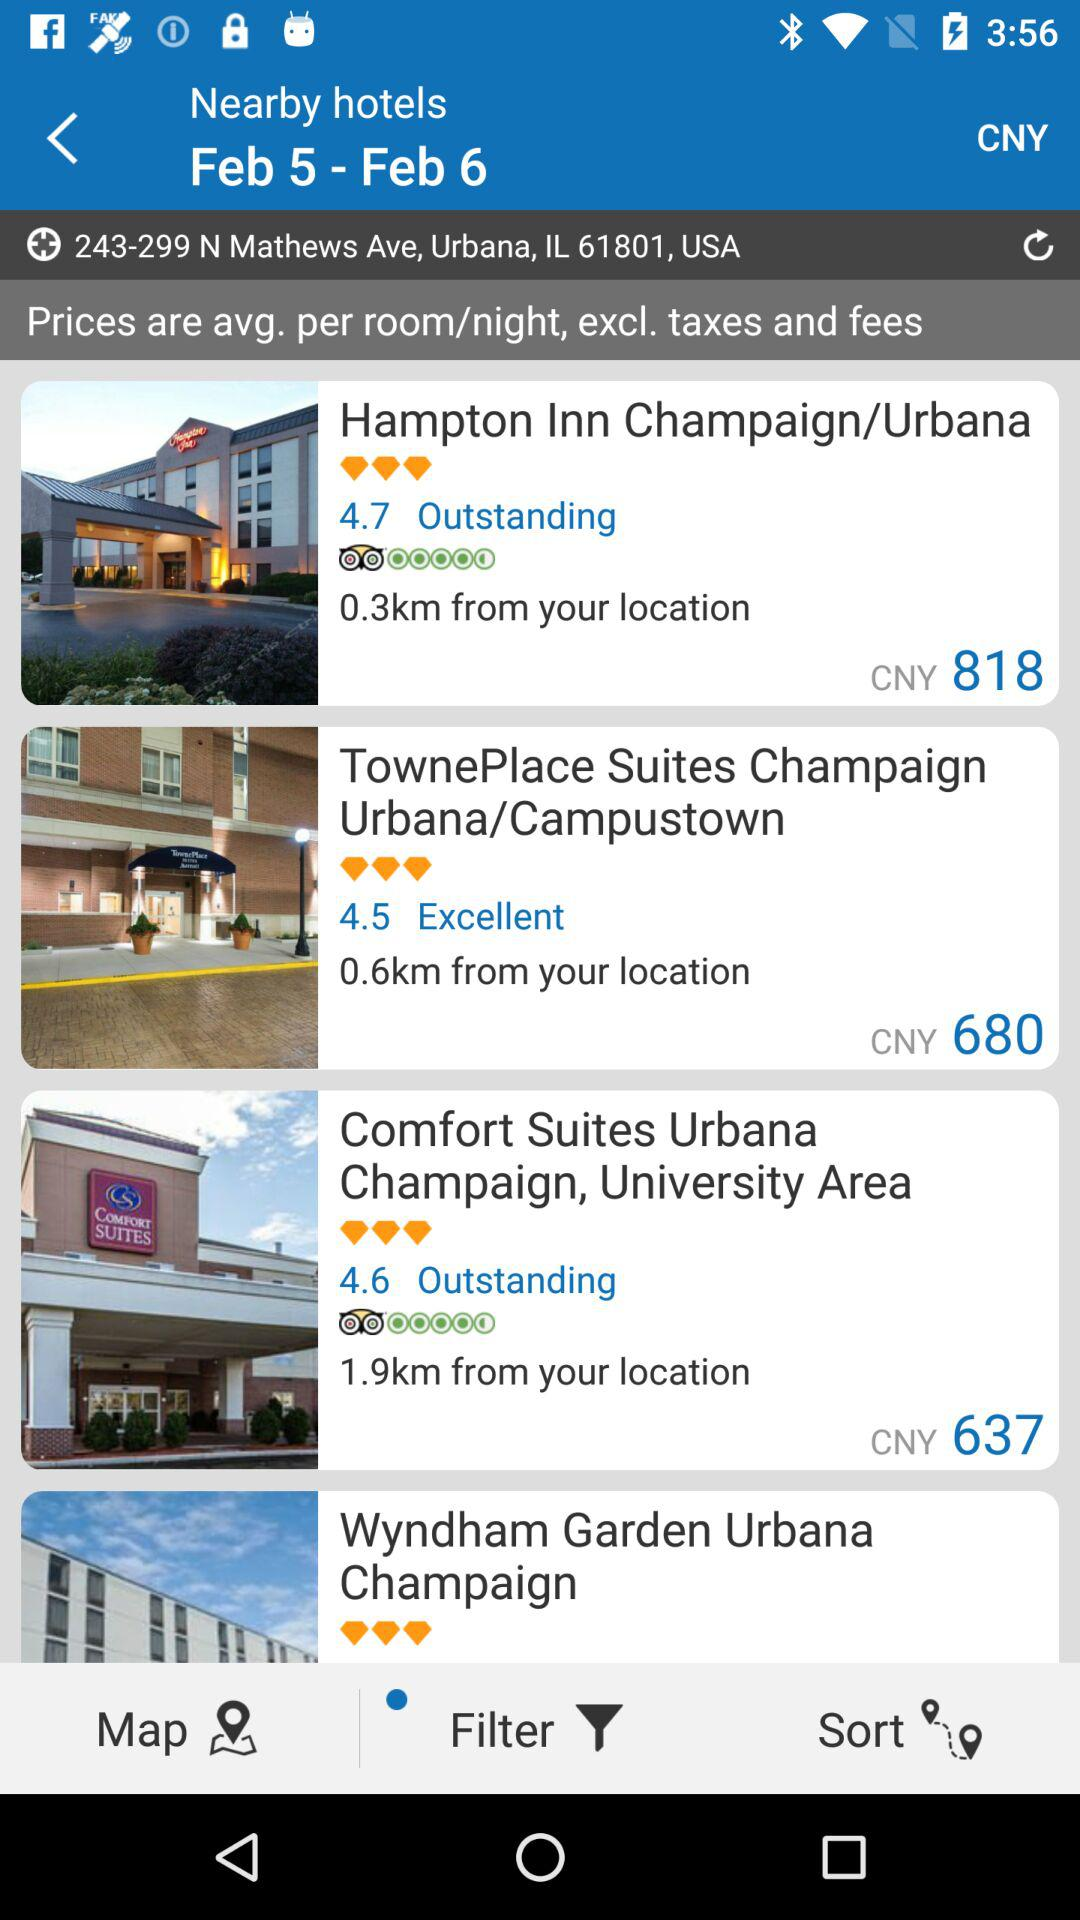What is the rating given to "TownePlace Suites Champaign Urbana/Campustown"? The given rating is 4.5. 